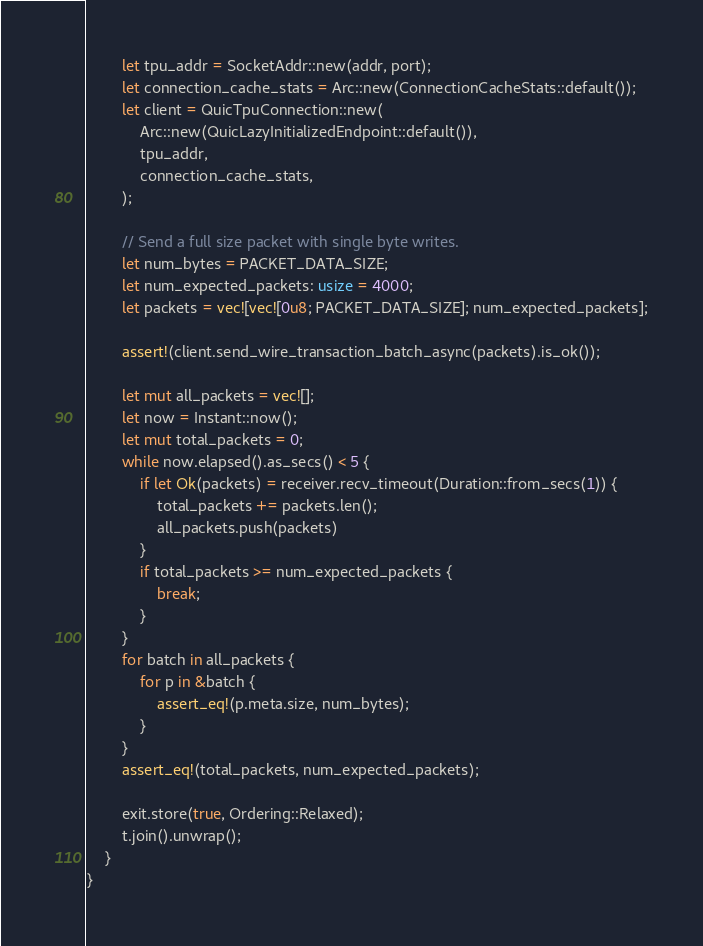<code> <loc_0><loc_0><loc_500><loc_500><_Rust_>        let tpu_addr = SocketAddr::new(addr, port);
        let connection_cache_stats = Arc::new(ConnectionCacheStats::default());
        let client = QuicTpuConnection::new(
            Arc::new(QuicLazyInitializedEndpoint::default()),
            tpu_addr,
            connection_cache_stats,
        );

        // Send a full size packet with single byte writes.
        let num_bytes = PACKET_DATA_SIZE;
        let num_expected_packets: usize = 4000;
        let packets = vec![vec![0u8; PACKET_DATA_SIZE]; num_expected_packets];

        assert!(client.send_wire_transaction_batch_async(packets).is_ok());

        let mut all_packets = vec![];
        let now = Instant::now();
        let mut total_packets = 0;
        while now.elapsed().as_secs() < 5 {
            if let Ok(packets) = receiver.recv_timeout(Duration::from_secs(1)) {
                total_packets += packets.len();
                all_packets.push(packets)
            }
            if total_packets >= num_expected_packets {
                break;
            }
        }
        for batch in all_packets {
            for p in &batch {
                assert_eq!(p.meta.size, num_bytes);
            }
        }
        assert_eq!(total_packets, num_expected_packets);

        exit.store(true, Ordering::Relaxed);
        t.join().unwrap();
    }
}
</code> 